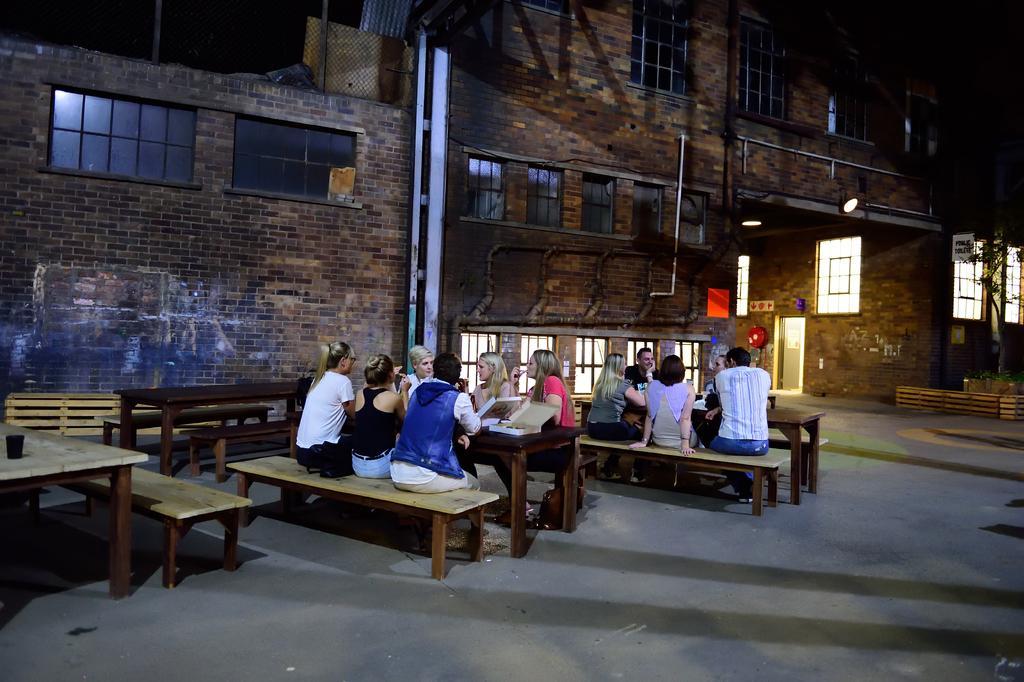Can you describe this image briefly? We can see in the image that there are many people sitting on a bench. This is a table and a building beside. 